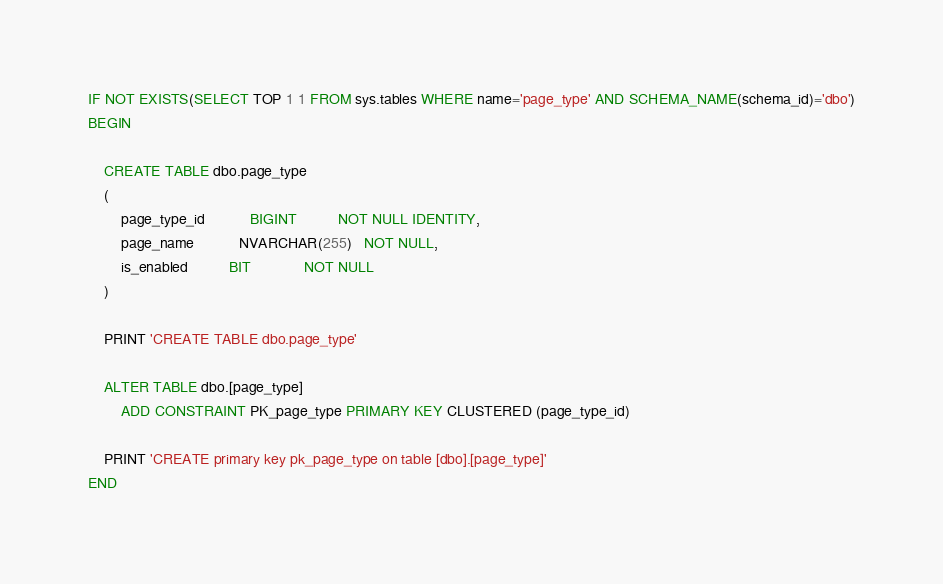Convert code to text. <code><loc_0><loc_0><loc_500><loc_500><_SQL_>IF NOT EXISTS(SELECT TOP 1 1 FROM sys.tables WHERE name='page_type' AND SCHEMA_NAME(schema_id)='dbo')
BEGIN

	CREATE TABLE dbo.page_type
	(
		page_type_id           BIGINT          NOT NULL IDENTITY,
		page_name           NVARCHAR(255)   NOT NULL,
		is_enabled          BIT             NOT NULL
	)

	PRINT 'CREATE TABLE dbo.page_type'

	ALTER TABLE dbo.[page_type]
	    ADD CONSTRAINT PK_page_type PRIMARY KEY CLUSTERED (page_type_id)

	PRINT 'CREATE primary key pk_page_type on table [dbo].[page_type]'
END
</code> 